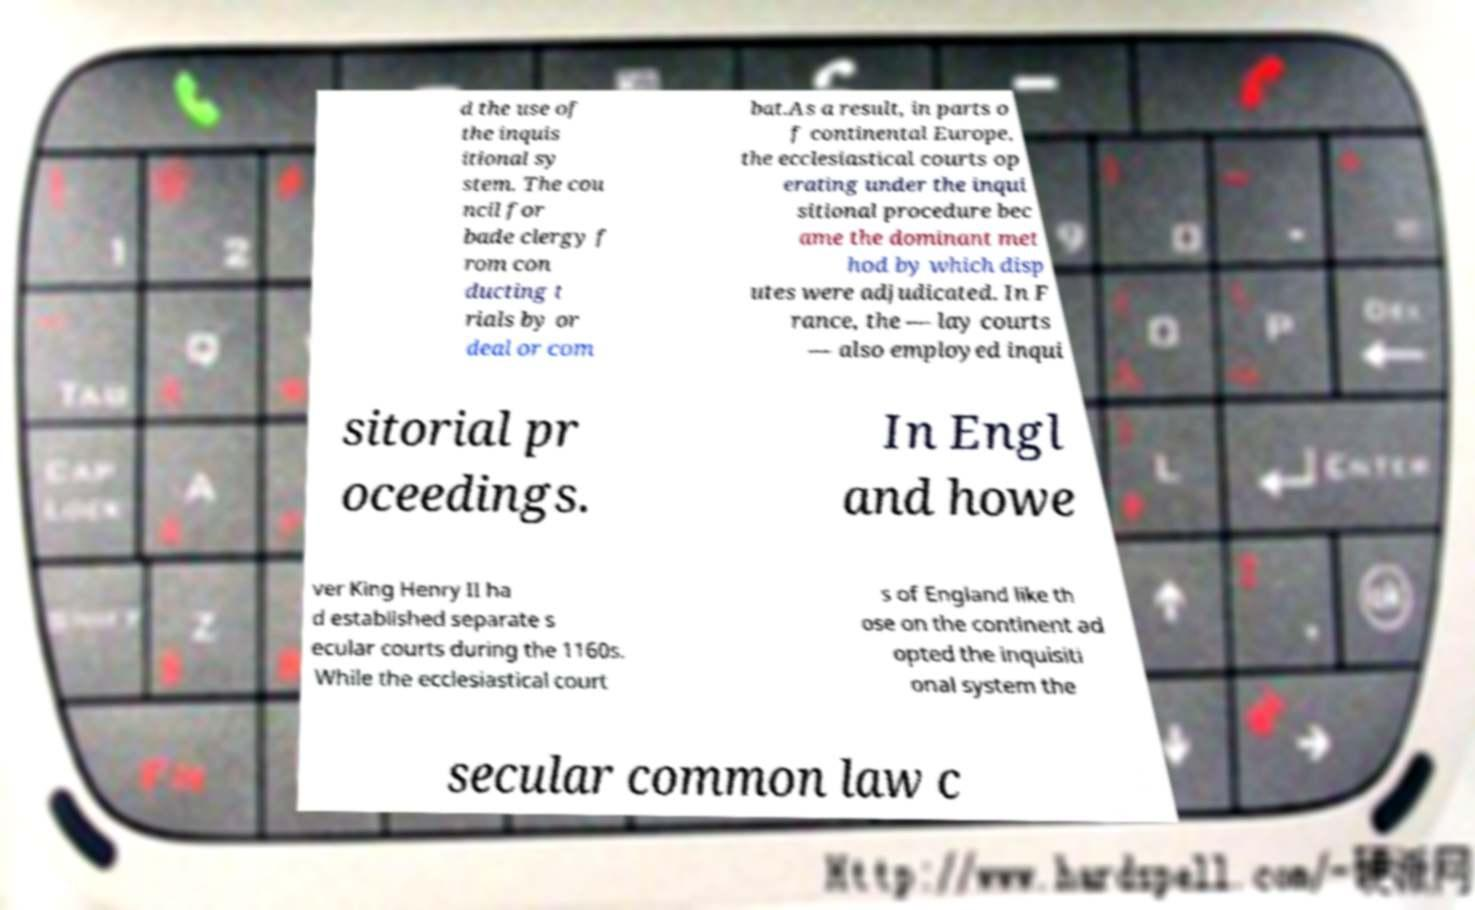Can you accurately transcribe the text from the provided image for me? d the use of the inquis itional sy stem. The cou ncil for bade clergy f rom con ducting t rials by or deal or com bat.As a result, in parts o f continental Europe, the ecclesiastical courts op erating under the inqui sitional procedure bec ame the dominant met hod by which disp utes were adjudicated. In F rance, the — lay courts — also employed inqui sitorial pr oceedings. In Engl and howe ver King Henry II ha d established separate s ecular courts during the 1160s. While the ecclesiastical court s of England like th ose on the continent ad opted the inquisiti onal system the secular common law c 